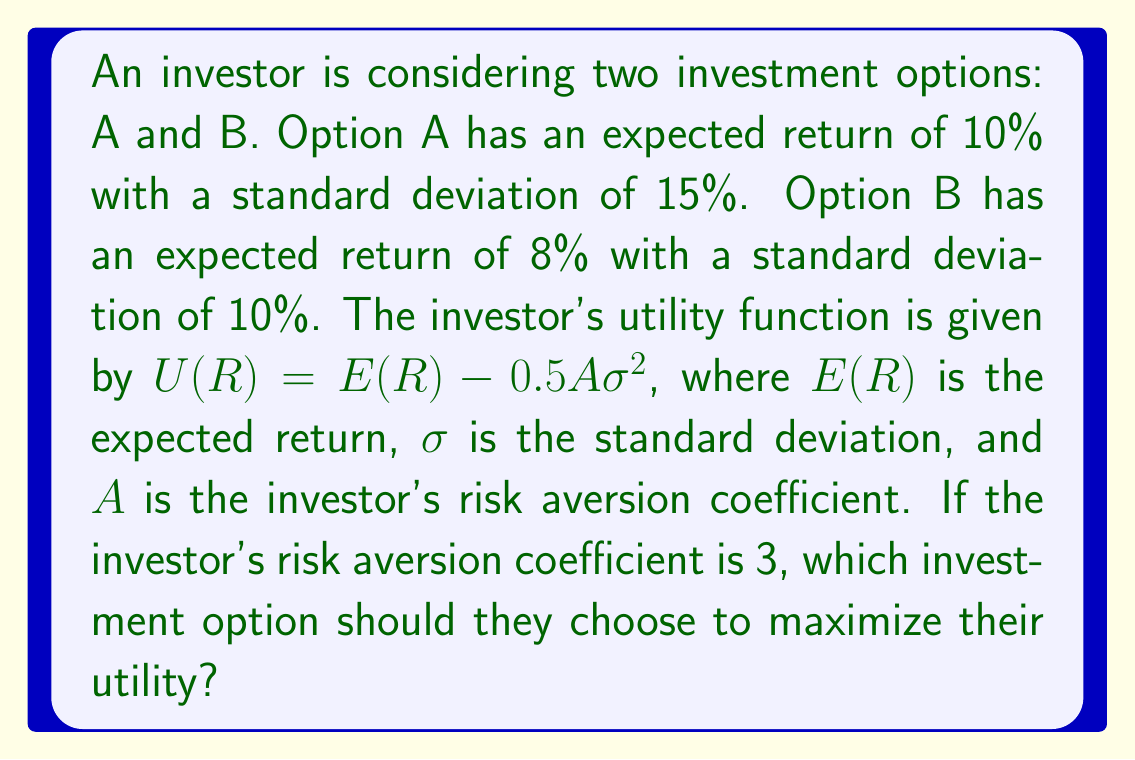Show me your answer to this math problem. To solve this problem, we need to calculate the utility for each investment option using the given utility function and compare them. Let's break it down step-by-step:

1. Utility function: $U(R) = E(R) - 0.5A\sigma^2$

2. Given information:
   Option A: $E(R_A) = 10\%$, $\sigma_A = 15\%$
   Option B: $E(R_B) = 8\%$, $\sigma_B = 10\%$
   Risk aversion coefficient: $A = 3$

3. Calculate utility for Option A:
   $$U(R_A) = E(R_A) - 0.5A\sigma_A^2$$
   $$U(R_A) = 0.10 - 0.5 \times 3 \times (0.15)^2$$
   $$U(R_A) = 0.10 - 0.5 \times 3 \times 0.0225$$
   $$U(R_A) = 0.10 - 0.03375$$
   $$U(R_A) = 0.06625 = 6.625\%$$

4. Calculate utility for Option B:
   $$U(R_B) = E(R_B) - 0.5A\sigma_B^2$$
   $$U(R_B) = 0.08 - 0.5 \times 3 \times (0.10)^2$$
   $$U(R_B) = 0.08 - 0.5 \times 3 \times 0.01$$
   $$U(R_B) = 0.08 - 0.015$$
   $$U(R_B) = 0.065 = 6.5\%$$

5. Compare the utilities:
   Option A utility: 6.625%
   Option B utility: 6.5%

Since the utility of Option A (6.625%) is higher than the utility of Option B (6.5%), the investor should choose Option A to maximize their utility.
Answer: The investor should choose Option A, which provides a higher utility of 6.625% compared to Option B's utility of 6.5%. 